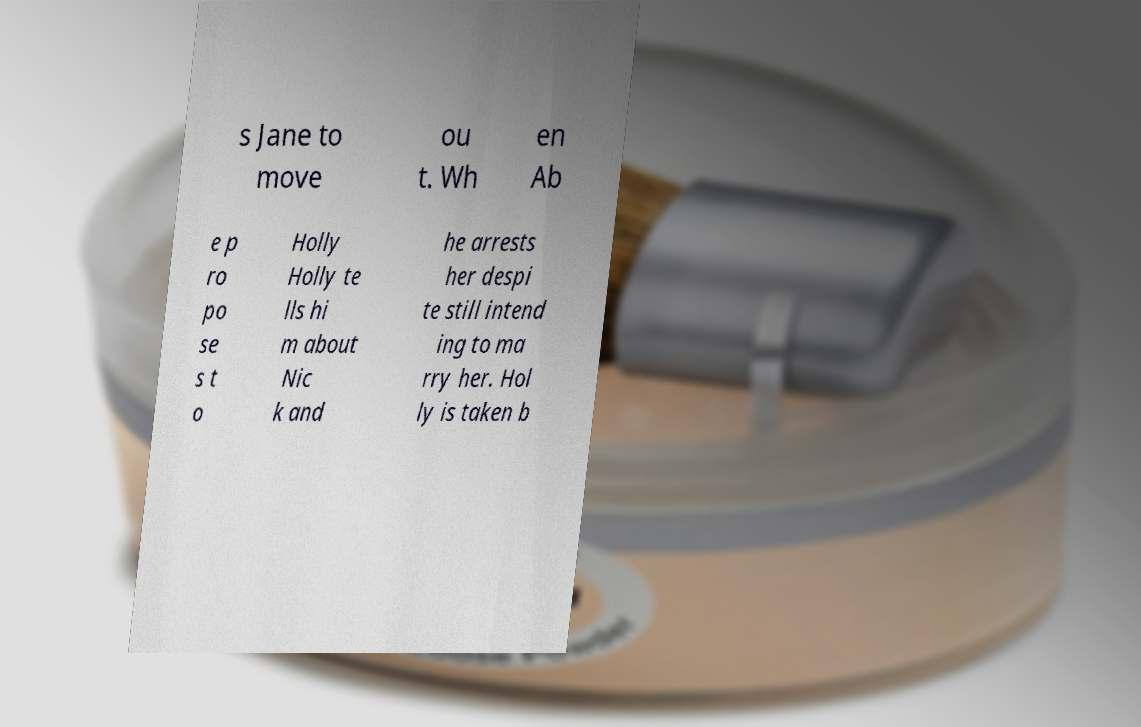There's text embedded in this image that I need extracted. Can you transcribe it verbatim? s Jane to move ou t. Wh en Ab e p ro po se s t o Holly Holly te lls hi m about Nic k and he arrests her despi te still intend ing to ma rry her. Hol ly is taken b 